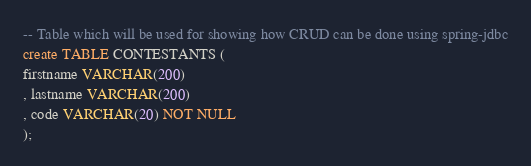<code> <loc_0><loc_0><loc_500><loc_500><_SQL_>-- Table which will be used for showing how CRUD can be done using spring-jdbc
create TABLE CONTESTANTS (
firstname VARCHAR(200)
, lastname VARCHAR(200)
, code VARCHAR(20) NOT NULL
);
</code> 